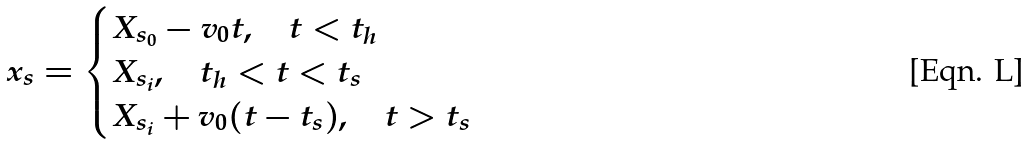<formula> <loc_0><loc_0><loc_500><loc_500>x _ { s } = \begin{cases} X _ { s _ { 0 } } - v _ { 0 } t , \quad t < t _ { h } \\ X _ { s _ { i } } , \quad t _ { h } < t < t _ { s } \\ X _ { s _ { i } } + v _ { 0 } ( t - t _ { s } ) , \quad t > t _ { s } \end{cases}</formula> 